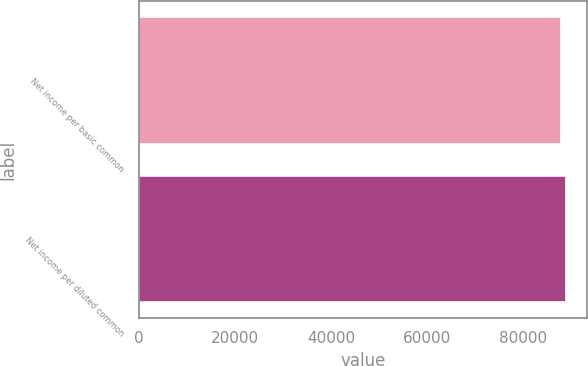Convert chart. <chart><loc_0><loc_0><loc_500><loc_500><bar_chart><fcel>Net income per basic common<fcel>Net income per diluted common<nl><fcel>87841<fcel>88979<nl></chart> 